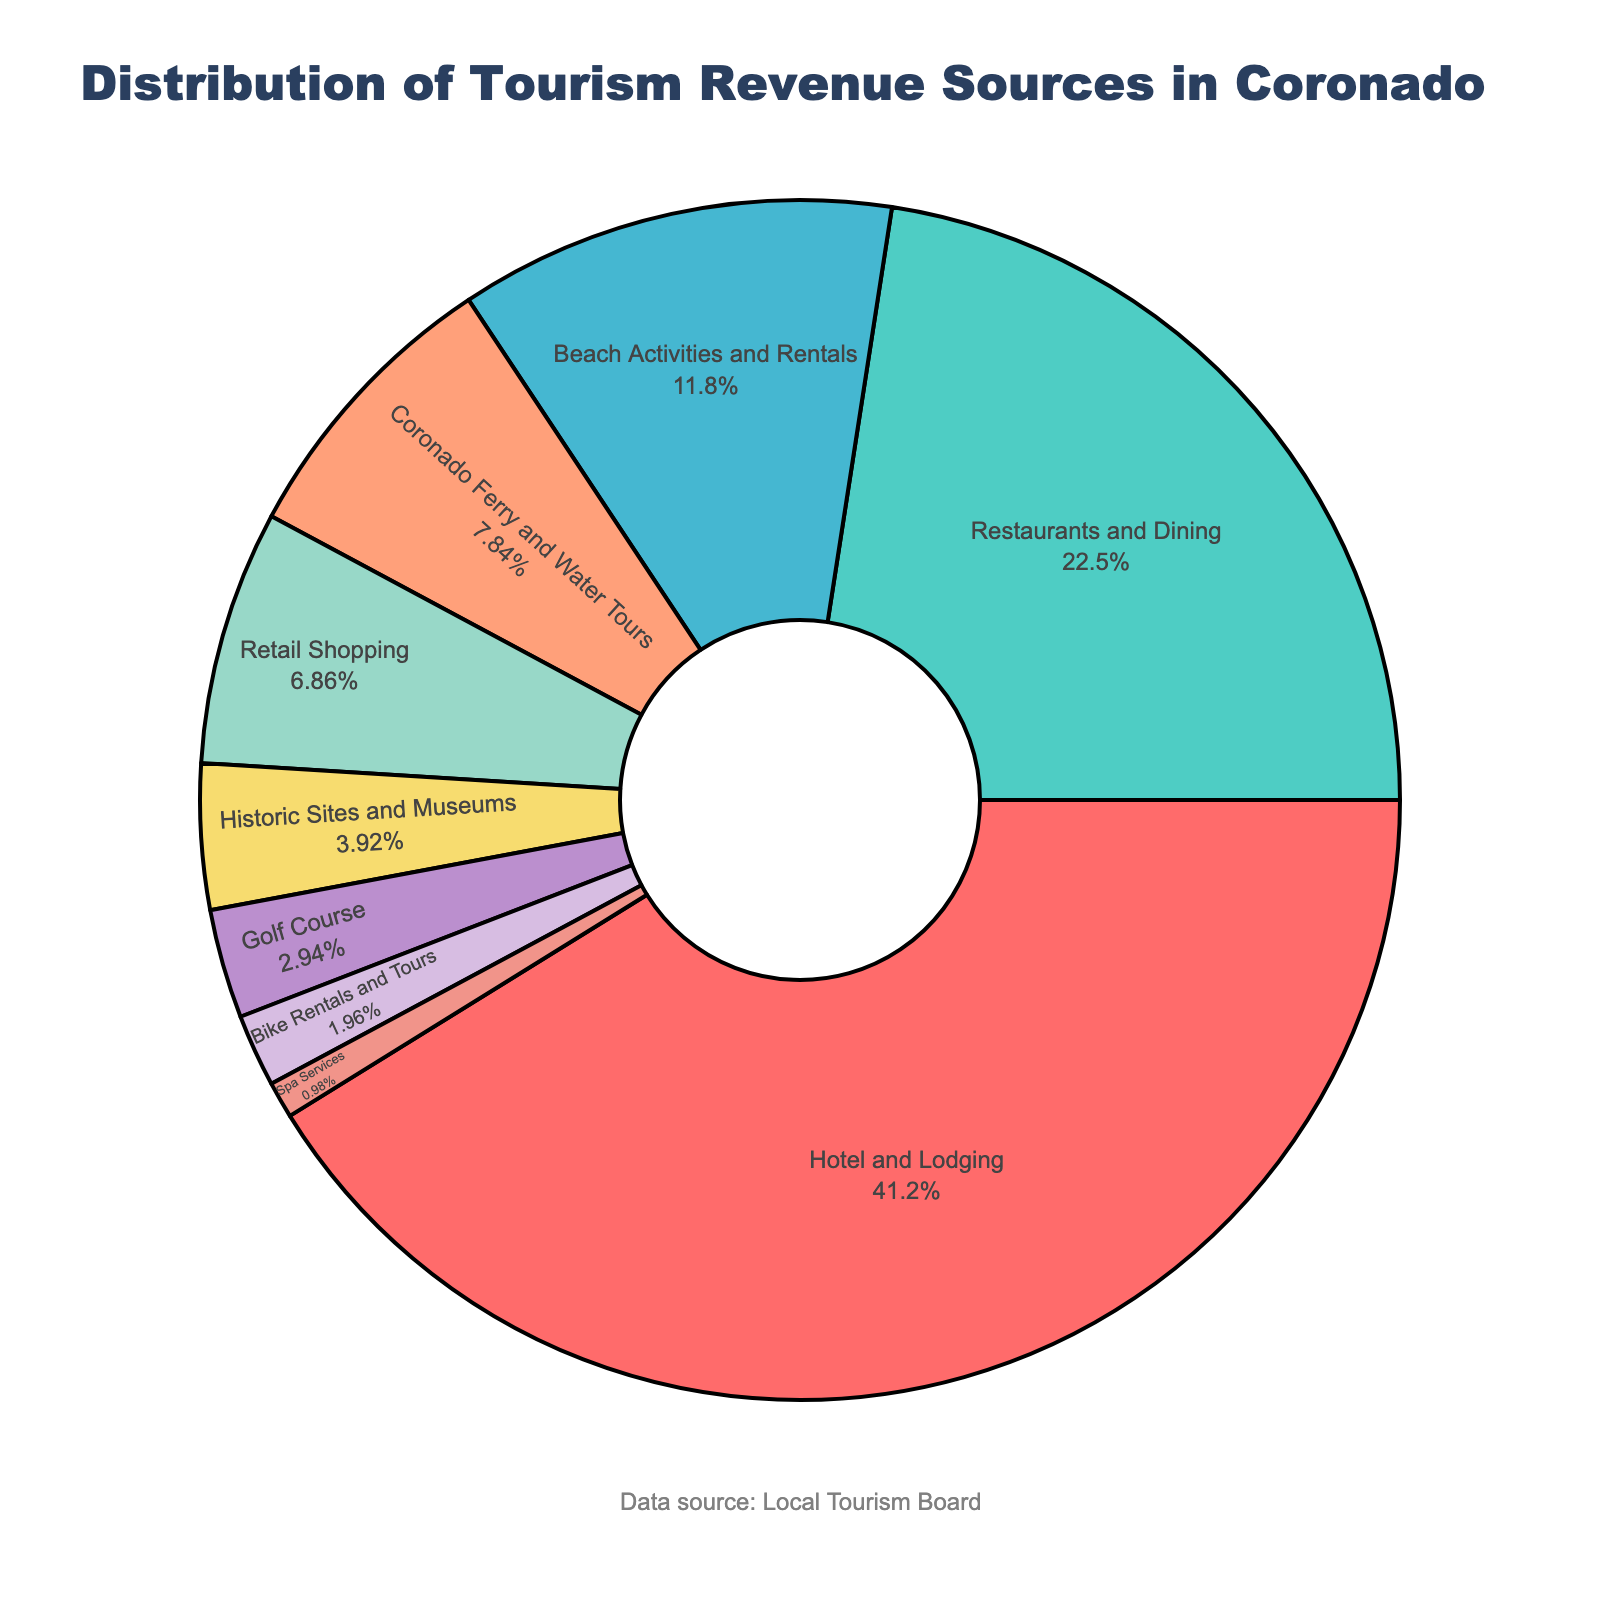What is the largest source of tourism revenue in Coronado? The largest slice of the pie chart corresponds to Hotel and Lodging, which has the largest percentage label attached to it.
Answer: Hotel and Lodging Which source contributes more to tourism revenue: Restaurants and Dining or Beach Activities and Rentals? Compare the percentages of Restaurants and Dining (23%) and Beach Activities and Rentals (12%) in the pie chart. Restaurants and Dining has a higher percentage.
Answer: Restaurants and Dining What is the combined percentage of revenue from Retail Shopping and Golf Course? Sum the percentages of Retail Shopping (7%) and Golf Course (3%). 7% + 3% = 10%.
Answer: 10% How much more percentage does Hotel and Lodging contribute compared to Coronado Ferry and Water Tours? Subtract the percentage of Coronado Ferry and Water Tours (8%) from Hotel and Lodging (42%). 42% - 8% = 34%.
Answer: 34% Which sector is represented by the smallest slice on the pie chart? The smallest slice of the pie chart, based on visual size, corresponds to Spa Services, which has the smallest percentage label.
Answer: Spa Services How much greater is the revenue percentage from Restaurants and Dining compared to Historic Sites and Museums? Subtract the percentage of Historic Sites and Museums (4%) from Restaurants and Dining (23%). 23% - 4% = 19%.
Answer: 19% What are the total combined percentages of the top three sources of tourism revenue? Sum the percentages of the top three sources: Hotel and Lodging (42%), Restaurants and Dining (23%), and Beach Activities and Rentals (12%). 42% + 23% + 12% = 77%.
Answer: 77% Which sources of revenue have a percentage less than 5%? Identify the sources that have a percentage less than 5% from the pie chart. These are Historic Sites and Museums (4%), Golf Course (3%), Bike Rentals and Tours (2%), and Spa Services (1%).
Answer: Historic Sites and Museums, Golf Course, Bike Rentals and Tours, Spa Services What color represents Coronado Ferry and Water Tours in the chart? Look for the slice labeled "Coronado Ferry and Water Tours" and note its color. It is represented in orange (#FFA07A).
Answer: orange If the percentage of Beach Activities and Rentals doubled, what would the new percentage be? Multiply the current percentage of Beach Activities and Rentals (12%) by 2. 12% * 2 = 24%.
Answer: 24% 